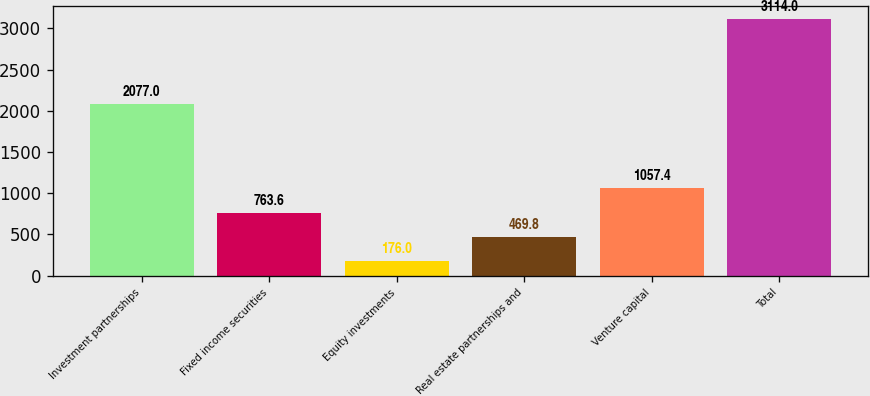Convert chart. <chart><loc_0><loc_0><loc_500><loc_500><bar_chart><fcel>Investment partnerships<fcel>Fixed income securities<fcel>Equity investments<fcel>Real estate partnerships and<fcel>Venture capital<fcel>Total<nl><fcel>2077<fcel>763.6<fcel>176<fcel>469.8<fcel>1057.4<fcel>3114<nl></chart> 